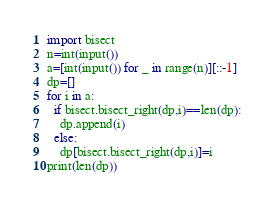<code> <loc_0><loc_0><loc_500><loc_500><_Python_>import bisect
n=int(input())
a=[int(input()) for _ in range(n)][::-1]
dp=[]
for i in a:
  if bisect.bisect_right(dp,i)==len(dp):
    dp.append(i)
  else:
    dp[bisect.bisect_right(dp,i)]=i
print(len(dp))</code> 